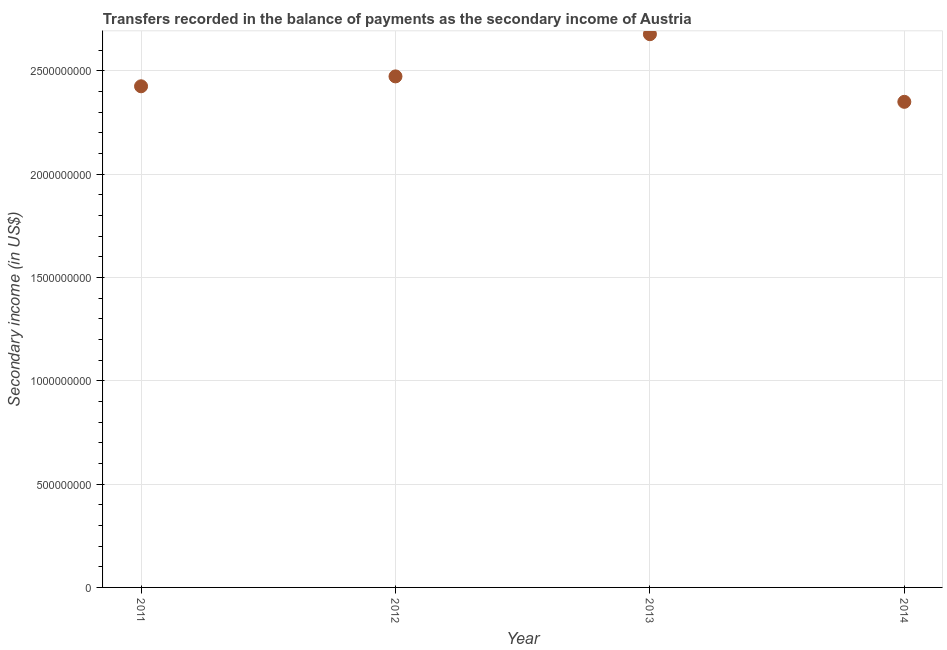What is the amount of secondary income in 2014?
Your response must be concise. 2.35e+09. Across all years, what is the maximum amount of secondary income?
Your answer should be compact. 2.68e+09. Across all years, what is the minimum amount of secondary income?
Ensure brevity in your answer.  2.35e+09. In which year was the amount of secondary income minimum?
Keep it short and to the point. 2014. What is the sum of the amount of secondary income?
Provide a succinct answer. 9.93e+09. What is the difference between the amount of secondary income in 2013 and 2014?
Offer a terse response. 3.27e+08. What is the average amount of secondary income per year?
Your answer should be very brief. 2.48e+09. What is the median amount of secondary income?
Keep it short and to the point. 2.45e+09. In how many years, is the amount of secondary income greater than 2400000000 US$?
Offer a very short reply. 3. Do a majority of the years between 2011 and 2013 (inclusive) have amount of secondary income greater than 400000000 US$?
Your answer should be very brief. Yes. What is the ratio of the amount of secondary income in 2011 to that in 2014?
Ensure brevity in your answer.  1.03. Is the amount of secondary income in 2013 less than that in 2014?
Keep it short and to the point. No. Is the difference between the amount of secondary income in 2012 and 2014 greater than the difference between any two years?
Your answer should be very brief. No. What is the difference between the highest and the second highest amount of secondary income?
Ensure brevity in your answer.  2.04e+08. What is the difference between the highest and the lowest amount of secondary income?
Your answer should be compact. 3.27e+08. In how many years, is the amount of secondary income greater than the average amount of secondary income taken over all years?
Keep it short and to the point. 1. Does the amount of secondary income monotonically increase over the years?
Provide a short and direct response. No. How many dotlines are there?
Offer a very short reply. 1. What is the difference between two consecutive major ticks on the Y-axis?
Provide a short and direct response. 5.00e+08. Does the graph contain grids?
Give a very brief answer. Yes. What is the title of the graph?
Ensure brevity in your answer.  Transfers recorded in the balance of payments as the secondary income of Austria. What is the label or title of the X-axis?
Keep it short and to the point. Year. What is the label or title of the Y-axis?
Ensure brevity in your answer.  Secondary income (in US$). What is the Secondary income (in US$) in 2011?
Make the answer very short. 2.43e+09. What is the Secondary income (in US$) in 2012?
Offer a very short reply. 2.47e+09. What is the Secondary income (in US$) in 2013?
Offer a very short reply. 2.68e+09. What is the Secondary income (in US$) in 2014?
Provide a short and direct response. 2.35e+09. What is the difference between the Secondary income (in US$) in 2011 and 2012?
Keep it short and to the point. -4.79e+07. What is the difference between the Secondary income (in US$) in 2011 and 2013?
Offer a terse response. -2.52e+08. What is the difference between the Secondary income (in US$) in 2011 and 2014?
Keep it short and to the point. 7.52e+07. What is the difference between the Secondary income (in US$) in 2012 and 2013?
Keep it short and to the point. -2.04e+08. What is the difference between the Secondary income (in US$) in 2012 and 2014?
Your answer should be compact. 1.23e+08. What is the difference between the Secondary income (in US$) in 2013 and 2014?
Offer a terse response. 3.27e+08. What is the ratio of the Secondary income (in US$) in 2011 to that in 2013?
Make the answer very short. 0.91. What is the ratio of the Secondary income (in US$) in 2011 to that in 2014?
Provide a succinct answer. 1.03. What is the ratio of the Secondary income (in US$) in 2012 to that in 2013?
Your response must be concise. 0.92. What is the ratio of the Secondary income (in US$) in 2012 to that in 2014?
Make the answer very short. 1.05. What is the ratio of the Secondary income (in US$) in 2013 to that in 2014?
Provide a short and direct response. 1.14. 